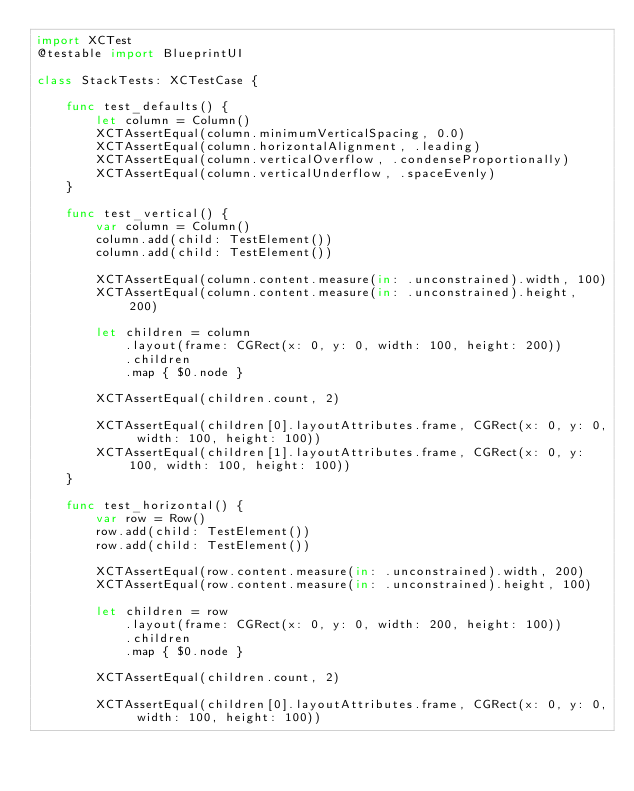Convert code to text. <code><loc_0><loc_0><loc_500><loc_500><_Swift_>import XCTest
@testable import BlueprintUI

class StackTests: XCTestCase {

    func test_defaults() {
        let column = Column()
        XCTAssertEqual(column.minimumVerticalSpacing, 0.0)
        XCTAssertEqual(column.horizontalAlignment, .leading)
        XCTAssertEqual(column.verticalOverflow, .condenseProportionally)
        XCTAssertEqual(column.verticalUnderflow, .spaceEvenly)
    }

    func test_vertical() {
        var column = Column()
        column.add(child: TestElement())
        column.add(child: TestElement())

        XCTAssertEqual(column.content.measure(in: .unconstrained).width, 100)
        XCTAssertEqual(column.content.measure(in: .unconstrained).height, 200)

        let children = column
            .layout(frame: CGRect(x: 0, y: 0, width: 100, height: 200))
            .children
            .map { $0.node }

        XCTAssertEqual(children.count, 2)

        XCTAssertEqual(children[0].layoutAttributes.frame, CGRect(x: 0, y: 0, width: 100, height: 100))
        XCTAssertEqual(children[1].layoutAttributes.frame, CGRect(x: 0, y: 100, width: 100, height: 100))
    }

    func test_horizontal() {
        var row = Row()
        row.add(child: TestElement())
        row.add(child: TestElement())

        XCTAssertEqual(row.content.measure(in: .unconstrained).width, 200)
        XCTAssertEqual(row.content.measure(in: .unconstrained).height, 100)

        let children = row
            .layout(frame: CGRect(x: 0, y: 0, width: 200, height: 100))
            .children
            .map { $0.node }

        XCTAssertEqual(children.count, 2)

        XCTAssertEqual(children[0].layoutAttributes.frame, CGRect(x: 0, y: 0, width: 100, height: 100))</code> 